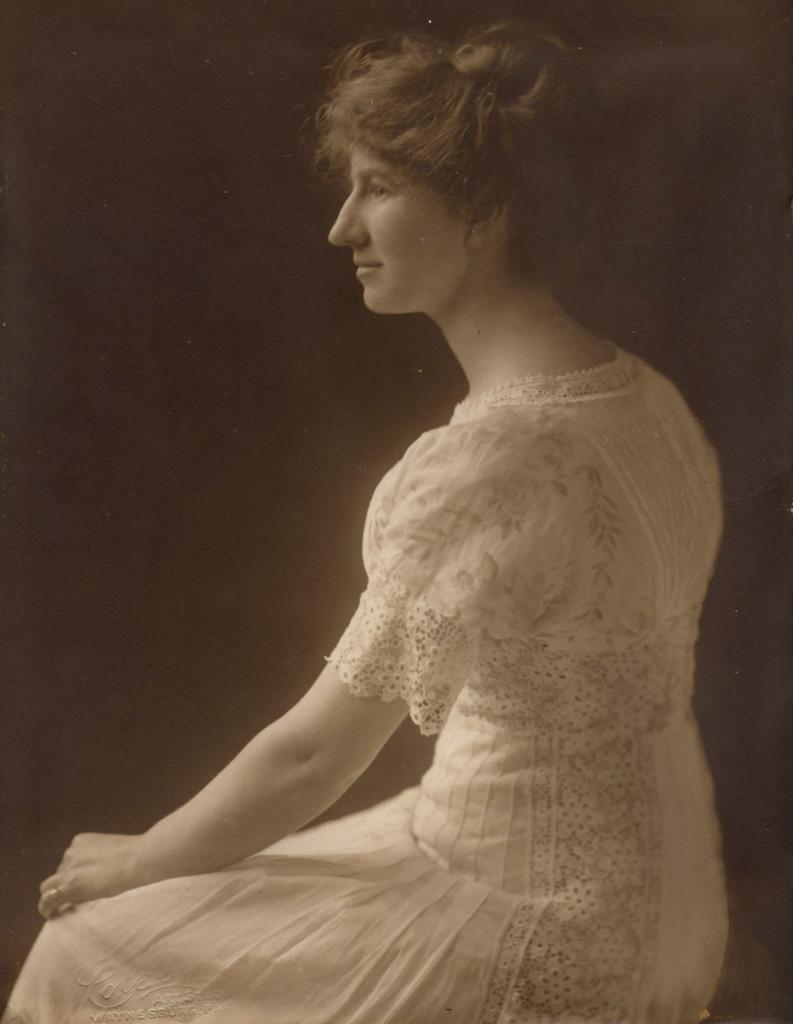Could you give a brief overview of what you see in this image? In this image there is a person sitting with a white dress, and there is dark background. 